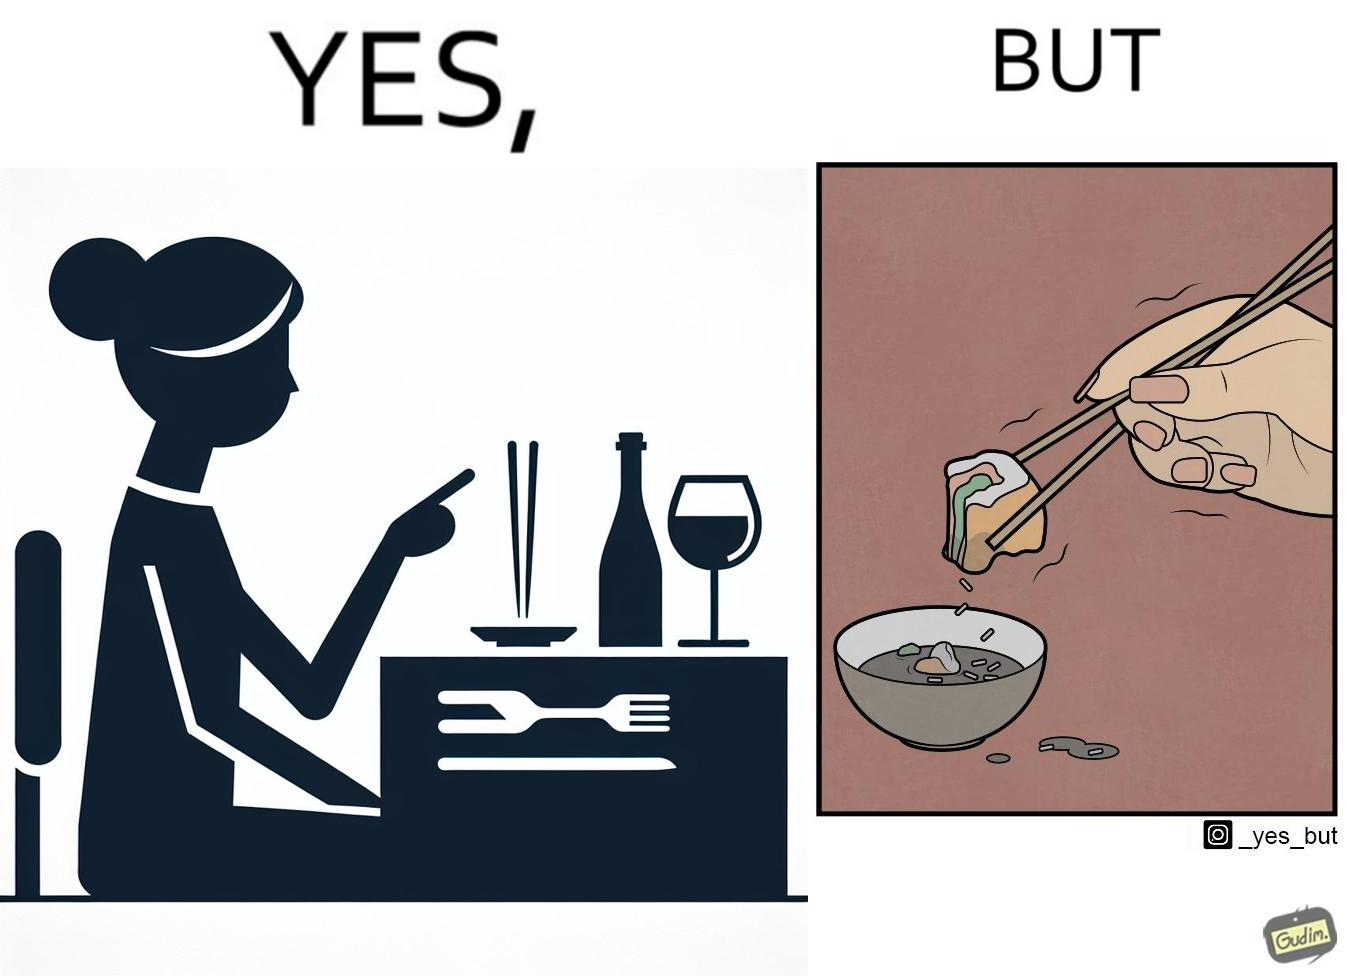Why is this image considered satirical? The image is satirical because even thought the woman is not able to eat food with chopstick properly, she chooses it over fork and knife to look sophisticaed. 